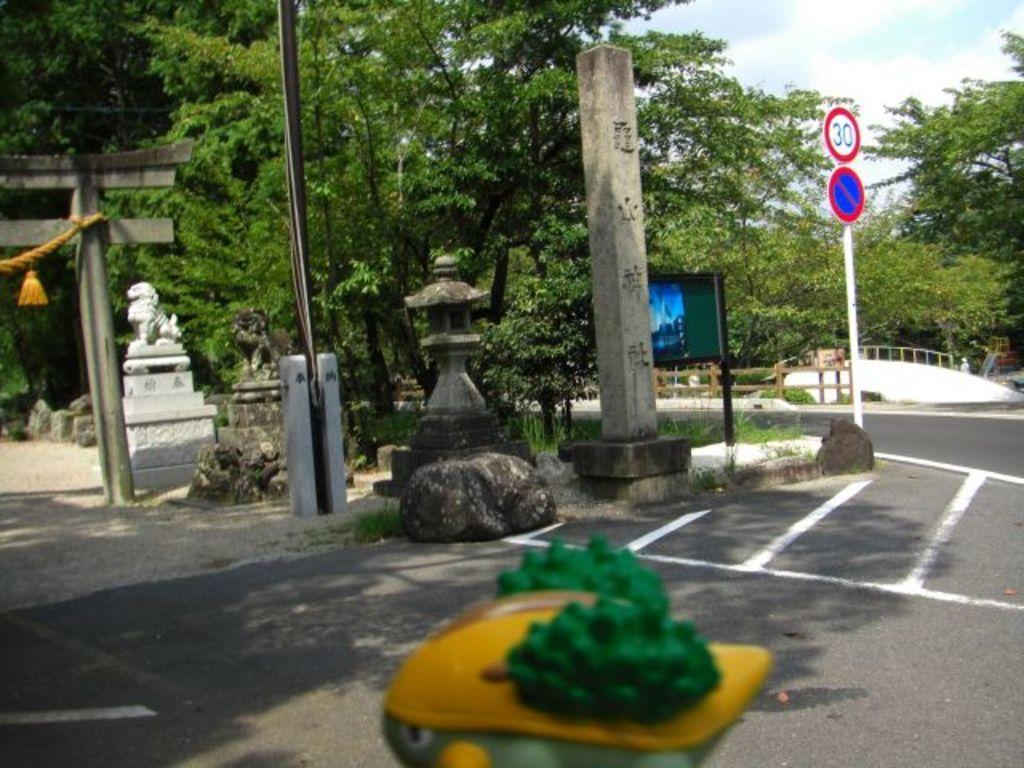In one or two sentences, can you explain what this image depicts? In the image we can see there are many trees and poles. We can even see a road and white lines on the road. Here we can see a sculpture, white in color. There is even a board, we can even see grass and cloudy pale blue sky. There are many stones around. 